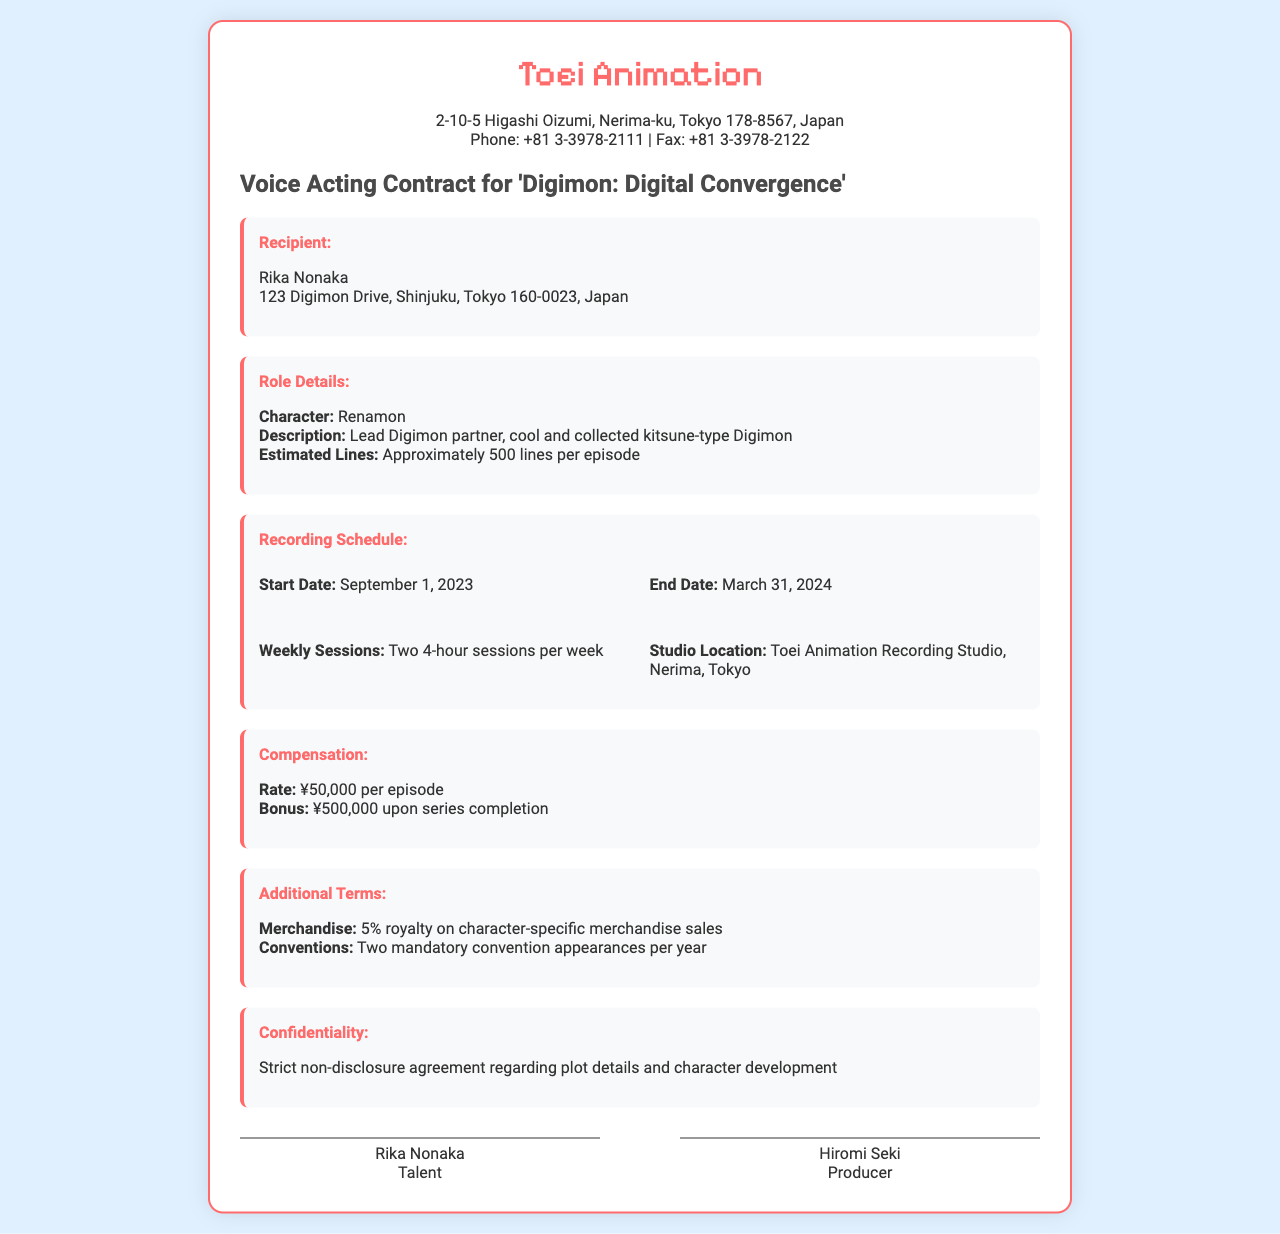What is the character name? The character name for the role is provided in the role details section of the document.
Answer: Renamon What is the recording start date? The start date for recording sessions is specified in the recording schedule section.
Answer: September 1, 2023 How many lines are estimated per episode? This information is listed under role details, stating how many lines the actor will have.
Answer: Approximately 500 lines What is the studio location? The studio location is clearly mentioned in the recording schedule section.
Answer: Toei Animation Recording Studio, Nerima, Tokyo What is the rate per episode? The compensation section outlines the rate per episode for the voice acting role.
Answer: ¥50,000 How many mandatory convention appearances are required per year? This detail can be found in the additional terms section, specifying the number of appearances.
Answer: Two What is the bonus upon series completion? The bonus amount after completing the series is indicated in the compensation section.
Answer: ¥500,000 What type of agreement is mentioned regarding plot details? The document includes a section on confidentiality which describes the type of agreement for plot details.
Answer: Non-disclosure agreement 